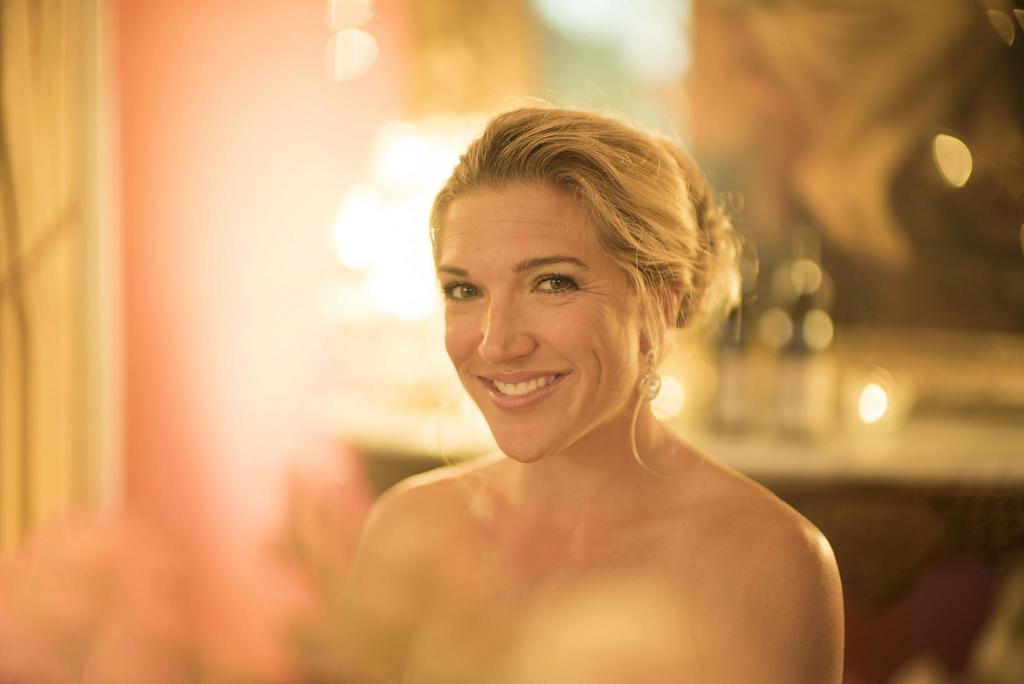Who is the main subject in the image? There is a lady in the image. What is the lady's facial expression? The lady has a smiling face. Can you describe the background of the image? The background of the image is blurry. What type of jeans is the lady wearing in the image? There is no mention of jeans in the image, so we cannot determine what type of jeans the lady is wearing. 